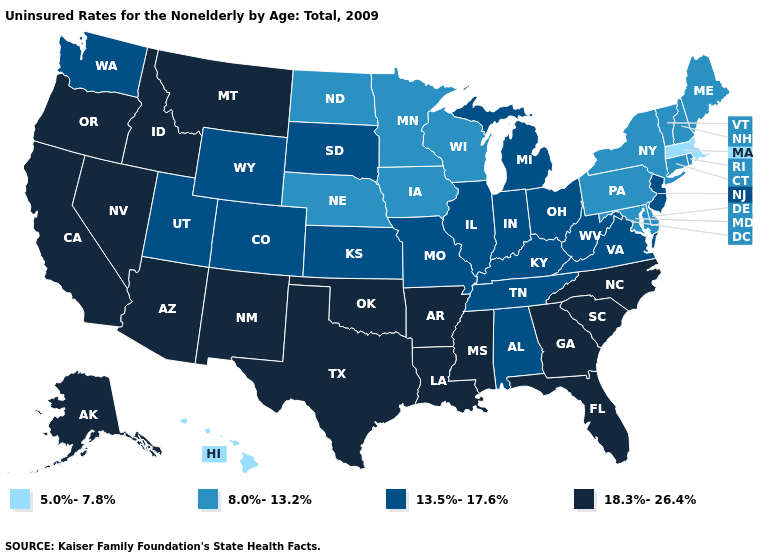Does the map have missing data?
Quick response, please. No. How many symbols are there in the legend?
Concise answer only. 4. What is the value of Delaware?
Be succinct. 8.0%-13.2%. Does Arkansas have the highest value in the USA?
Short answer required. Yes. Is the legend a continuous bar?
Keep it brief. No. Name the states that have a value in the range 13.5%-17.6%?
Short answer required. Alabama, Colorado, Illinois, Indiana, Kansas, Kentucky, Michigan, Missouri, New Jersey, Ohio, South Dakota, Tennessee, Utah, Virginia, Washington, West Virginia, Wyoming. Name the states that have a value in the range 13.5%-17.6%?
Quick response, please. Alabama, Colorado, Illinois, Indiana, Kansas, Kentucky, Michigan, Missouri, New Jersey, Ohio, South Dakota, Tennessee, Utah, Virginia, Washington, West Virginia, Wyoming. Name the states that have a value in the range 18.3%-26.4%?
Short answer required. Alaska, Arizona, Arkansas, California, Florida, Georgia, Idaho, Louisiana, Mississippi, Montana, Nevada, New Mexico, North Carolina, Oklahoma, Oregon, South Carolina, Texas. Name the states that have a value in the range 18.3%-26.4%?
Answer briefly. Alaska, Arizona, Arkansas, California, Florida, Georgia, Idaho, Louisiana, Mississippi, Montana, Nevada, New Mexico, North Carolina, Oklahoma, Oregon, South Carolina, Texas. Which states have the highest value in the USA?
Answer briefly. Alaska, Arizona, Arkansas, California, Florida, Georgia, Idaho, Louisiana, Mississippi, Montana, Nevada, New Mexico, North Carolina, Oklahoma, Oregon, South Carolina, Texas. Name the states that have a value in the range 13.5%-17.6%?
Short answer required. Alabama, Colorado, Illinois, Indiana, Kansas, Kentucky, Michigan, Missouri, New Jersey, Ohio, South Dakota, Tennessee, Utah, Virginia, Washington, West Virginia, Wyoming. What is the value of Hawaii?
Short answer required. 5.0%-7.8%. What is the value of Washington?
Be succinct. 13.5%-17.6%. Name the states that have a value in the range 5.0%-7.8%?
Give a very brief answer. Hawaii, Massachusetts. 